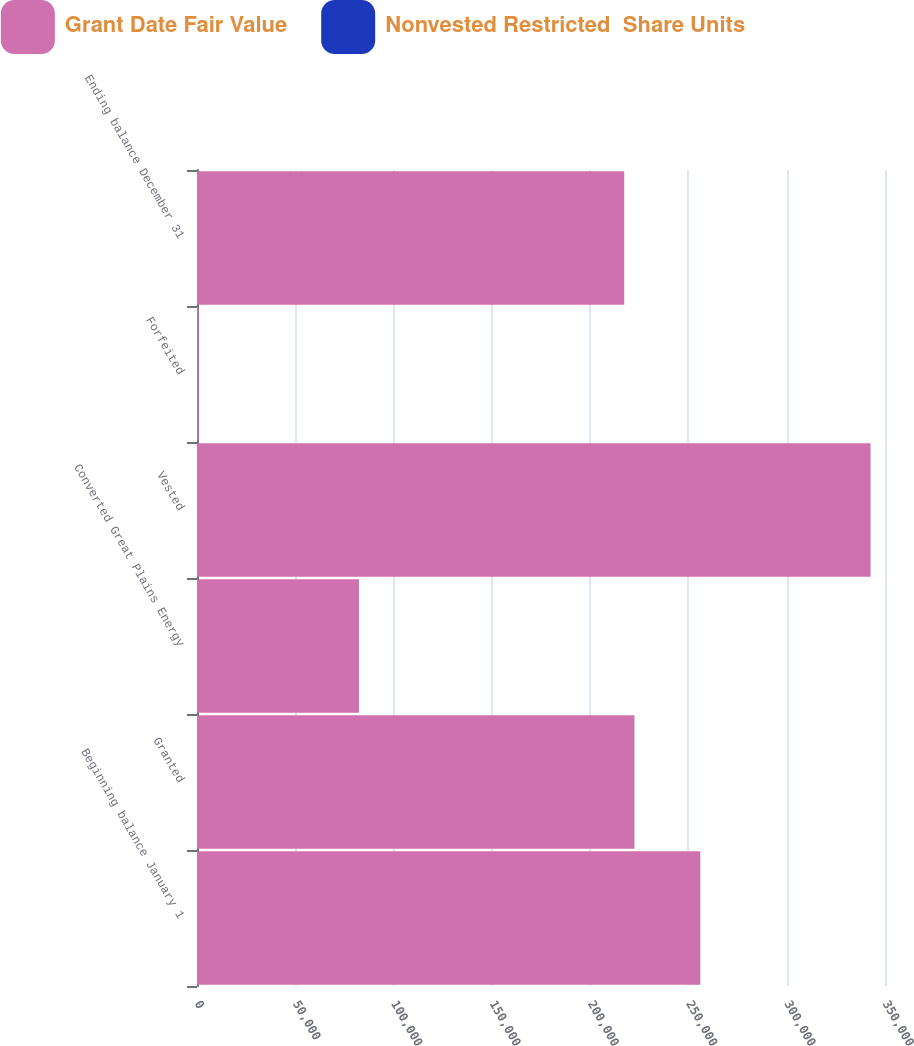Convert chart. <chart><loc_0><loc_0><loc_500><loc_500><stacked_bar_chart><ecel><fcel>Beginning balance January 1<fcel>Granted<fcel>Converted Great Plains Energy<fcel>Vested<fcel>Forfeited<fcel>Ending balance December 31<nl><fcel>Grant Date Fair Value<fcel>255964<fcel>222465<fcel>82331<fcel>342599<fcel>905<fcel>217256<nl><fcel>Nonvested Restricted  Share Units<fcel>46.09<fcel>52.16<fcel>53.77<fcel>46.81<fcel>50.73<fcel>54.07<nl></chart> 